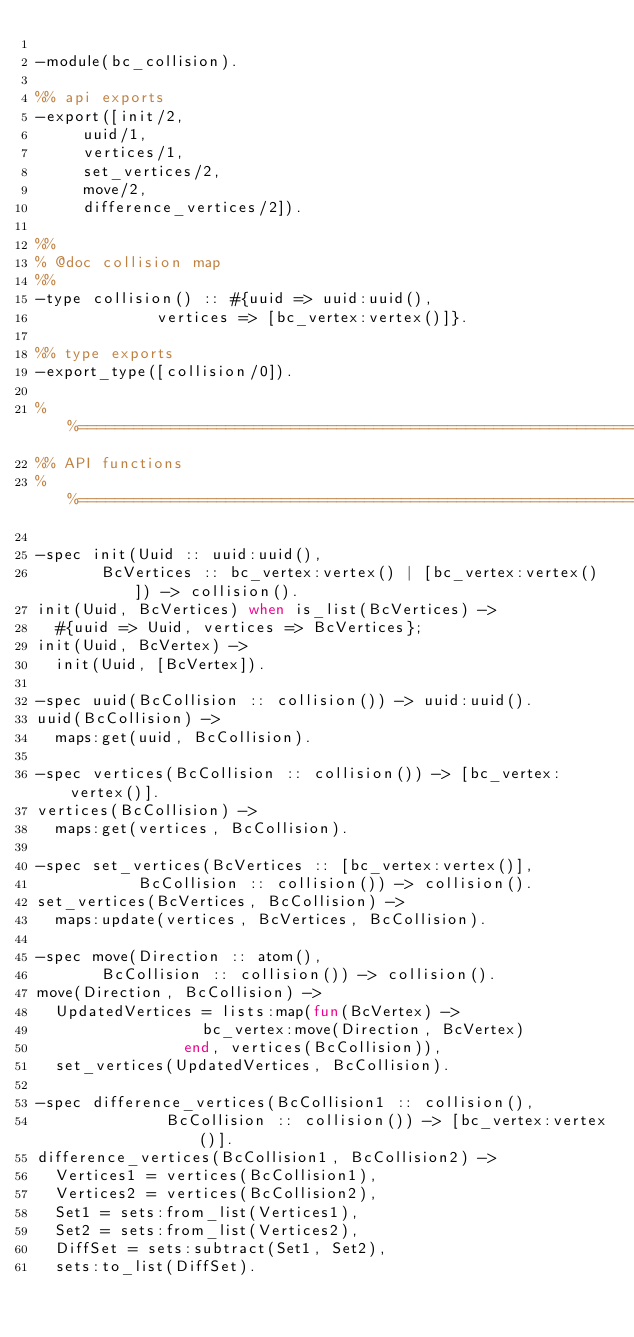<code> <loc_0><loc_0><loc_500><loc_500><_Erlang_>
-module(bc_collision).

%% api exports
-export([init/2, 
		 uuid/1, 
		 vertices/1,
		 set_vertices/2,
		 move/2,
		 difference_vertices/2]).

%%
% @doc collision map
%%
-type collision() :: #{uuid => uuid:uuid(), 
					   vertices => [bc_vertex:vertex()]}.

%% type exports 
-export_type([collision/0]).

%%====================================================================
%% API functions
%%====================================================================

-spec init(Uuid :: uuid:uuid(),
		   BcVertices :: bc_vertex:vertex() | [bc_vertex:vertex()]) -> collision().
init(Uuid, BcVertices) when is_list(BcVertices) ->
	#{uuid => Uuid, vertices => BcVertices};
init(Uuid, BcVertex) ->
	init(Uuid, [BcVertex]).

-spec uuid(BcCollision :: collision()) -> uuid:uuid().
uuid(BcCollision) ->
	maps:get(uuid, BcCollision).

-spec vertices(BcCollision :: collision()) -> [bc_vertex:vertex()].
vertices(BcCollision) ->
	maps:get(vertices, BcCollision).

-spec set_vertices(BcVertices :: [bc_vertex:vertex()], 
				   BcCollision :: collision()) -> collision().
set_vertices(BcVertices, BcCollision) ->
	maps:update(vertices, BcVertices, BcCollision).

-spec move(Direction :: atom(), 
		   BcCollision :: collision()) -> collision().
move(Direction, BcCollision) ->
	UpdatedVertices = lists:map(fun(BcVertex) -> 
									bc_vertex:move(Direction, BcVertex) 
								end, vertices(BcCollision)),
	set_vertices(UpdatedVertices, BcCollision).

-spec difference_vertices(BcCollision1 :: collision(), 
						  BcCollision :: collision()) -> [bc_vertex:vertex()].
difference_vertices(BcCollision1, BcCollision2) ->
	Vertices1 = vertices(BcCollision1),
	Vertices2 = vertices(BcCollision2),
	Set1 = sets:from_list(Vertices1),
	Set2 = sets:from_list(Vertices2),
	DiffSet = sets:subtract(Set1, Set2),
	sets:to_list(DiffSet).</code> 